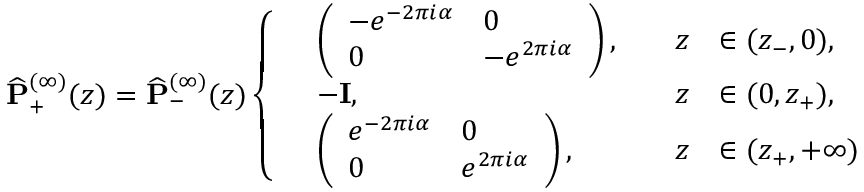Convert formula to latex. <formula><loc_0><loc_0><loc_500><loc_500>\widehat { P } _ { + } ^ { ( \infty ) } ( z ) = \widehat { P } _ { - } ^ { ( \infty ) } ( z ) \left \{ \begin{array} { r l r l } & { \left ( \begin{array} { l l } { - e ^ { - 2 \pi i \alpha } } & { 0 } \\ { 0 } & { - e ^ { 2 \pi i \alpha } } \end{array} \right ) , \quad } & { z } & { \in ( z _ { - } , 0 ) , } \\ & { - I , \quad } & { z } & { \in ( 0 , z _ { + } ) , } \\ & { \left ( \begin{array} { l l } { e ^ { - 2 \pi i \alpha } } & { 0 } \\ { 0 } & { e ^ { 2 \pi i \alpha } } \end{array} \right ) , \quad } & { z } & { \in ( z _ { + } , + \infty ) } \end{array}</formula> 